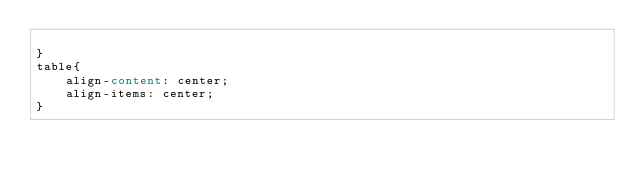Convert code to text. <code><loc_0><loc_0><loc_500><loc_500><_CSS_>
}
table{
	align-content: center;
	align-items: center;
}
</code> 